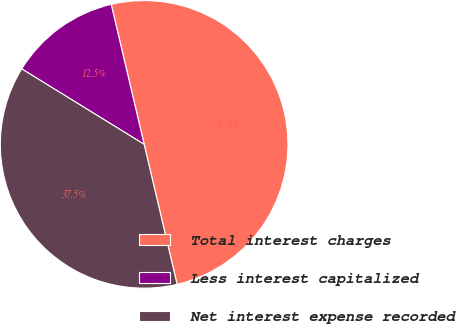<chart> <loc_0><loc_0><loc_500><loc_500><pie_chart><fcel>Total interest charges<fcel>Less interest capitalized<fcel>Net interest expense recorded<nl><fcel>50.0%<fcel>12.53%<fcel>37.47%<nl></chart> 